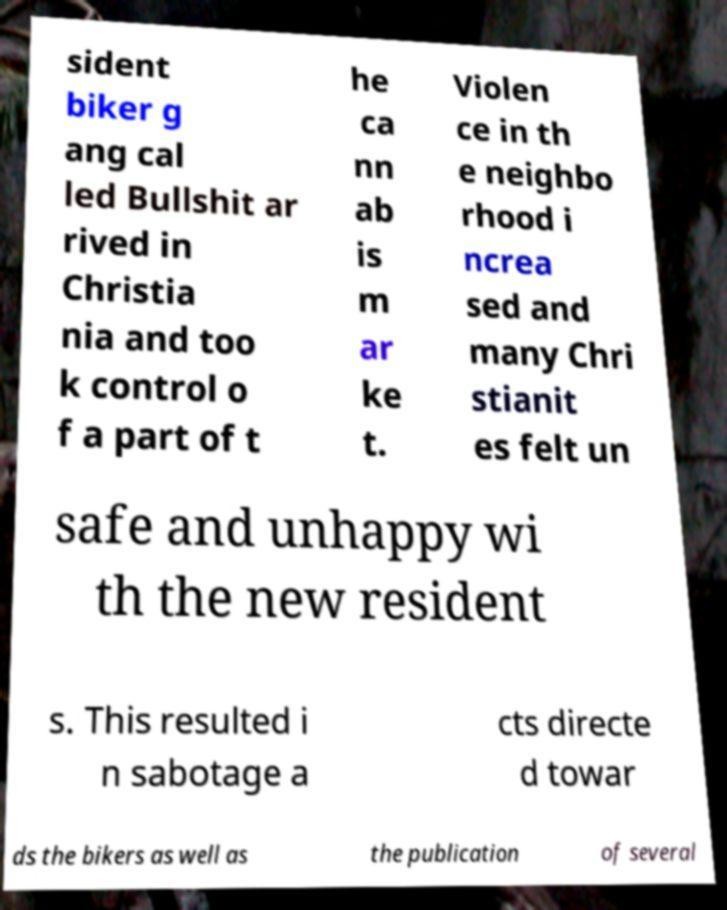Can you read and provide the text displayed in the image?This photo seems to have some interesting text. Can you extract and type it out for me? sident biker g ang cal led Bullshit ar rived in Christia nia and too k control o f a part of t he ca nn ab is m ar ke t. Violen ce in th e neighbo rhood i ncrea sed and many Chri stianit es felt un safe and unhappy wi th the new resident s. This resulted i n sabotage a cts directe d towar ds the bikers as well as the publication of several 